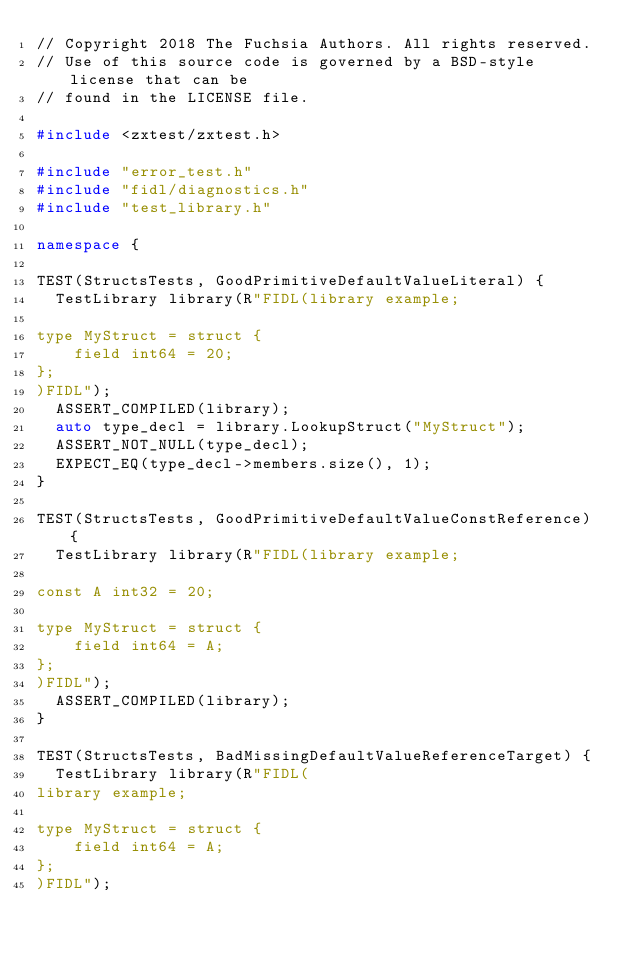Convert code to text. <code><loc_0><loc_0><loc_500><loc_500><_C++_>// Copyright 2018 The Fuchsia Authors. All rights reserved.
// Use of this source code is governed by a BSD-style license that can be
// found in the LICENSE file.

#include <zxtest/zxtest.h>

#include "error_test.h"
#include "fidl/diagnostics.h"
#include "test_library.h"

namespace {

TEST(StructsTests, GoodPrimitiveDefaultValueLiteral) {
  TestLibrary library(R"FIDL(library example;

type MyStruct = struct {
    field int64 = 20;
};
)FIDL");
  ASSERT_COMPILED(library);
  auto type_decl = library.LookupStruct("MyStruct");
  ASSERT_NOT_NULL(type_decl);
  EXPECT_EQ(type_decl->members.size(), 1);
}

TEST(StructsTests, GoodPrimitiveDefaultValueConstReference) {
  TestLibrary library(R"FIDL(library example;

const A int32 = 20;

type MyStruct = struct {
    field int64 = A;
};
)FIDL");
  ASSERT_COMPILED(library);
}

TEST(StructsTests, BadMissingDefaultValueReferenceTarget) {
  TestLibrary library(R"FIDL(
library example;

type MyStruct = struct {
    field int64 = A;
};
)FIDL");</code> 